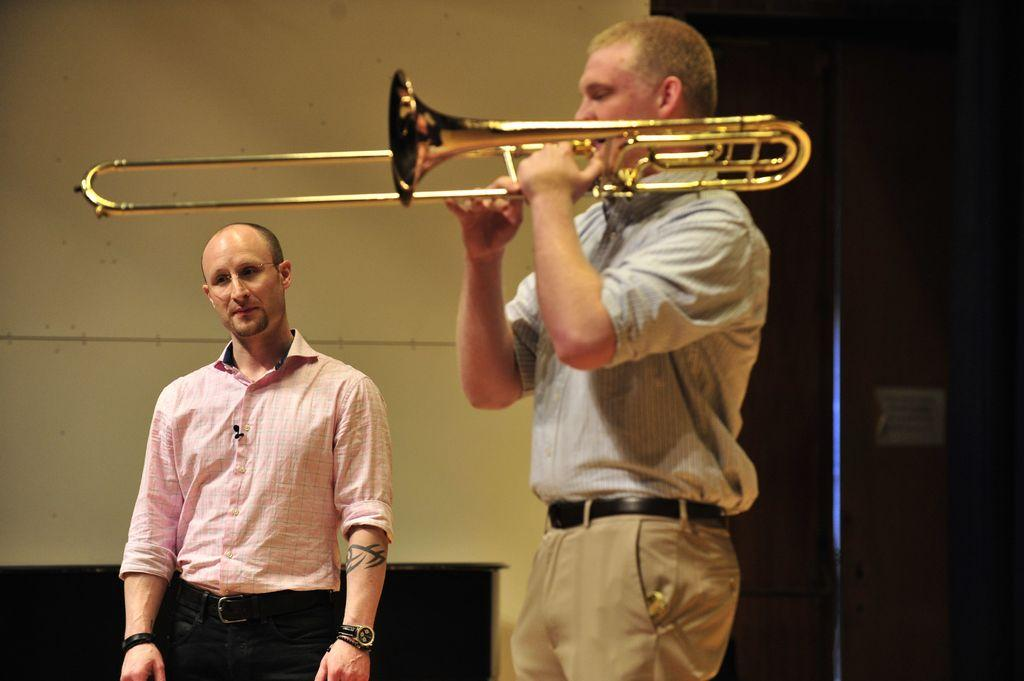How many people are the people are in the image? There are two people standing in the image. What is the man holding in the image? The man is holding a trombone. What can be seen in the background of the image? There is a wall and an object in the background of the image. What hobbies do the people in the image have? There is no information about the hobbies of the people in the image. When was the birth of the person holding the trombone? There is no information about the birth of the person holding the trombone in the image. 